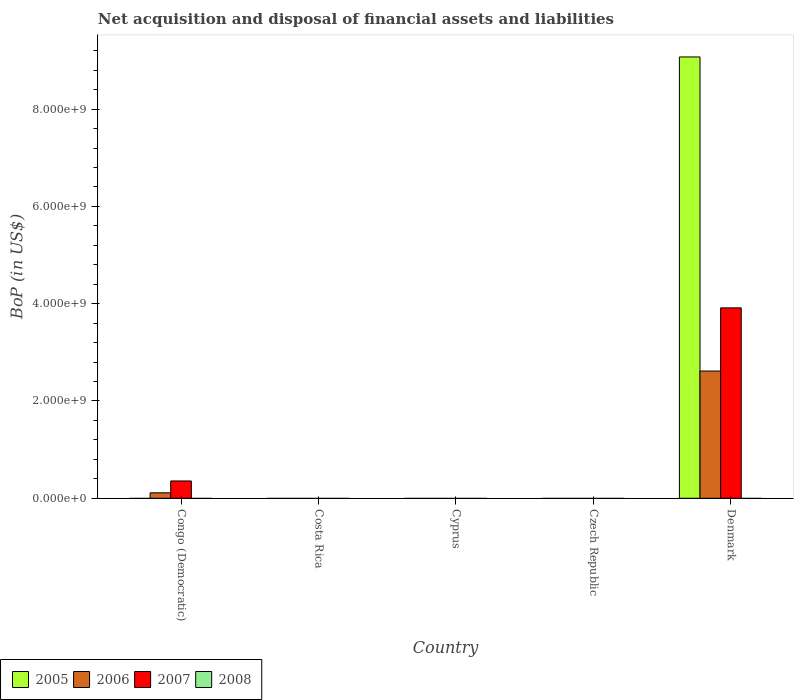Are the number of bars per tick equal to the number of legend labels?
Provide a short and direct response. No. Are the number of bars on each tick of the X-axis equal?
Ensure brevity in your answer.  No. How many bars are there on the 4th tick from the left?
Provide a short and direct response. 0. What is the Balance of Payments in 2007 in Cyprus?
Your response must be concise. 0. Across all countries, what is the maximum Balance of Payments in 2006?
Offer a terse response. 2.62e+09. Across all countries, what is the minimum Balance of Payments in 2007?
Offer a terse response. 0. In which country was the Balance of Payments in 2006 maximum?
Offer a terse response. Denmark. What is the total Balance of Payments in 2007 in the graph?
Your response must be concise. 4.27e+09. What is the difference between the Balance of Payments in 2006 in Congo (Democratic) and that in Denmark?
Ensure brevity in your answer.  -2.50e+09. What is the average Balance of Payments in 2005 per country?
Your answer should be compact. 1.81e+09. What is the difference between the Balance of Payments of/in 2005 and Balance of Payments of/in 2007 in Denmark?
Give a very brief answer. 5.16e+09. In how many countries, is the Balance of Payments in 2006 greater than 2400000000 US$?
Ensure brevity in your answer.  1. What is the difference between the highest and the lowest Balance of Payments in 2007?
Your response must be concise. 3.91e+09. Is it the case that in every country, the sum of the Balance of Payments in 2008 and Balance of Payments in 2006 is greater than the Balance of Payments in 2005?
Your response must be concise. No. What is the difference between two consecutive major ticks on the Y-axis?
Give a very brief answer. 2.00e+09. Are the values on the major ticks of Y-axis written in scientific E-notation?
Your response must be concise. Yes. Does the graph contain grids?
Provide a succinct answer. No. Where does the legend appear in the graph?
Your answer should be compact. Bottom left. How many legend labels are there?
Your answer should be very brief. 4. What is the title of the graph?
Make the answer very short. Net acquisition and disposal of financial assets and liabilities. Does "1983" appear as one of the legend labels in the graph?
Ensure brevity in your answer.  No. What is the label or title of the Y-axis?
Your answer should be very brief. BoP (in US$). What is the BoP (in US$) of 2005 in Congo (Democratic)?
Give a very brief answer. 0. What is the BoP (in US$) of 2006 in Congo (Democratic)?
Make the answer very short. 1.12e+08. What is the BoP (in US$) in 2007 in Congo (Democratic)?
Offer a terse response. 3.56e+08. What is the BoP (in US$) in 2006 in Costa Rica?
Keep it short and to the point. 0. What is the BoP (in US$) in 2005 in Cyprus?
Offer a very short reply. 0. What is the BoP (in US$) of 2006 in Cyprus?
Your response must be concise. 0. What is the BoP (in US$) of 2007 in Cyprus?
Keep it short and to the point. 0. What is the BoP (in US$) of 2005 in Czech Republic?
Keep it short and to the point. 0. What is the BoP (in US$) of 2006 in Czech Republic?
Give a very brief answer. 0. What is the BoP (in US$) of 2007 in Czech Republic?
Make the answer very short. 0. What is the BoP (in US$) of 2008 in Czech Republic?
Make the answer very short. 0. What is the BoP (in US$) of 2005 in Denmark?
Provide a succinct answer. 9.07e+09. What is the BoP (in US$) of 2006 in Denmark?
Offer a very short reply. 2.62e+09. What is the BoP (in US$) of 2007 in Denmark?
Keep it short and to the point. 3.91e+09. What is the BoP (in US$) of 2008 in Denmark?
Give a very brief answer. 0. Across all countries, what is the maximum BoP (in US$) of 2005?
Ensure brevity in your answer.  9.07e+09. Across all countries, what is the maximum BoP (in US$) in 2006?
Offer a terse response. 2.62e+09. Across all countries, what is the maximum BoP (in US$) in 2007?
Give a very brief answer. 3.91e+09. Across all countries, what is the minimum BoP (in US$) in 2005?
Make the answer very short. 0. Across all countries, what is the minimum BoP (in US$) of 2007?
Keep it short and to the point. 0. What is the total BoP (in US$) in 2005 in the graph?
Offer a terse response. 9.07e+09. What is the total BoP (in US$) in 2006 in the graph?
Give a very brief answer. 2.73e+09. What is the total BoP (in US$) of 2007 in the graph?
Give a very brief answer. 4.27e+09. What is the difference between the BoP (in US$) in 2006 in Congo (Democratic) and that in Denmark?
Ensure brevity in your answer.  -2.50e+09. What is the difference between the BoP (in US$) in 2007 in Congo (Democratic) and that in Denmark?
Give a very brief answer. -3.56e+09. What is the difference between the BoP (in US$) of 2006 in Congo (Democratic) and the BoP (in US$) of 2007 in Denmark?
Keep it short and to the point. -3.80e+09. What is the average BoP (in US$) in 2005 per country?
Your answer should be very brief. 1.81e+09. What is the average BoP (in US$) of 2006 per country?
Your answer should be very brief. 5.46e+08. What is the average BoP (in US$) in 2007 per country?
Provide a succinct answer. 8.54e+08. What is the difference between the BoP (in US$) of 2006 and BoP (in US$) of 2007 in Congo (Democratic)?
Offer a very short reply. -2.44e+08. What is the difference between the BoP (in US$) of 2005 and BoP (in US$) of 2006 in Denmark?
Ensure brevity in your answer.  6.46e+09. What is the difference between the BoP (in US$) in 2005 and BoP (in US$) in 2007 in Denmark?
Offer a very short reply. 5.16e+09. What is the difference between the BoP (in US$) of 2006 and BoP (in US$) of 2007 in Denmark?
Your response must be concise. -1.30e+09. What is the ratio of the BoP (in US$) in 2006 in Congo (Democratic) to that in Denmark?
Offer a terse response. 0.04. What is the ratio of the BoP (in US$) in 2007 in Congo (Democratic) to that in Denmark?
Your answer should be very brief. 0.09. What is the difference between the highest and the lowest BoP (in US$) in 2005?
Offer a terse response. 9.07e+09. What is the difference between the highest and the lowest BoP (in US$) of 2006?
Offer a very short reply. 2.62e+09. What is the difference between the highest and the lowest BoP (in US$) of 2007?
Your answer should be compact. 3.91e+09. 